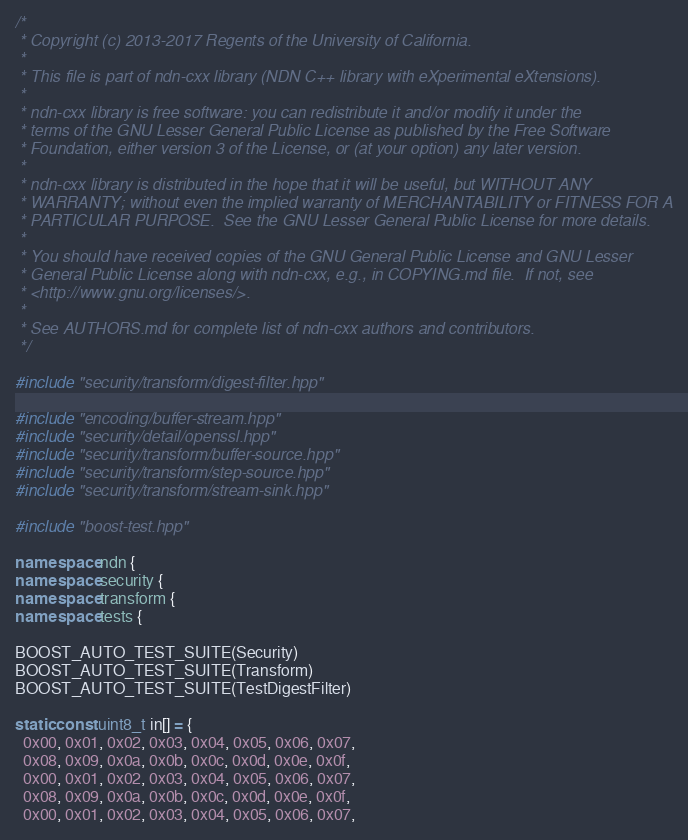<code> <loc_0><loc_0><loc_500><loc_500><_C++_>/*
 * Copyright (c) 2013-2017 Regents of the University of California.
 *
 * This file is part of ndn-cxx library (NDN C++ library with eXperimental eXtensions).
 *
 * ndn-cxx library is free software: you can redistribute it and/or modify it under the
 * terms of the GNU Lesser General Public License as published by the Free Software
 * Foundation, either version 3 of the License, or (at your option) any later version.
 *
 * ndn-cxx library is distributed in the hope that it will be useful, but WITHOUT ANY
 * WARRANTY; without even the implied warranty of MERCHANTABILITY or FITNESS FOR A
 * PARTICULAR PURPOSE.  See the GNU Lesser General Public License for more details.
 *
 * You should have received copies of the GNU General Public License and GNU Lesser
 * General Public License along with ndn-cxx, e.g., in COPYING.md file.  If not, see
 * <http://www.gnu.org/licenses/>.
 *
 * See AUTHORS.md for complete list of ndn-cxx authors and contributors.
 */

#include "security/transform/digest-filter.hpp"

#include "encoding/buffer-stream.hpp"
#include "security/detail/openssl.hpp"
#include "security/transform/buffer-source.hpp"
#include "security/transform/step-source.hpp"
#include "security/transform/stream-sink.hpp"

#include "boost-test.hpp"

namespace ndn {
namespace security {
namespace transform {
namespace tests {

BOOST_AUTO_TEST_SUITE(Security)
BOOST_AUTO_TEST_SUITE(Transform)
BOOST_AUTO_TEST_SUITE(TestDigestFilter)

static const uint8_t in[] = {
  0x00, 0x01, 0x02, 0x03, 0x04, 0x05, 0x06, 0x07,
  0x08, 0x09, 0x0a, 0x0b, 0x0c, 0x0d, 0x0e, 0x0f,
  0x00, 0x01, 0x02, 0x03, 0x04, 0x05, 0x06, 0x07,
  0x08, 0x09, 0x0a, 0x0b, 0x0c, 0x0d, 0x0e, 0x0f,
  0x00, 0x01, 0x02, 0x03, 0x04, 0x05, 0x06, 0x07,</code> 